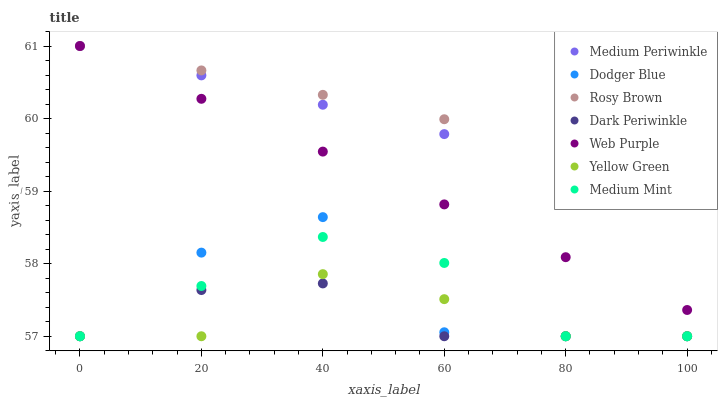Does Dark Periwinkle have the minimum area under the curve?
Answer yes or no. Yes. Does Rosy Brown have the maximum area under the curve?
Answer yes or no. Yes. Does Yellow Green have the minimum area under the curve?
Answer yes or no. No. Does Yellow Green have the maximum area under the curve?
Answer yes or no. No. Is Web Purple the smoothest?
Answer yes or no. Yes. Is Dodger Blue the roughest?
Answer yes or no. Yes. Is Yellow Green the smoothest?
Answer yes or no. No. Is Yellow Green the roughest?
Answer yes or no. No. Does Medium Mint have the lowest value?
Answer yes or no. Yes. Does Rosy Brown have the lowest value?
Answer yes or no. No. Does Web Purple have the highest value?
Answer yes or no. Yes. Does Yellow Green have the highest value?
Answer yes or no. No. Is Yellow Green less than Rosy Brown?
Answer yes or no. Yes. Is Web Purple greater than Dodger Blue?
Answer yes or no. Yes. Does Dark Periwinkle intersect Medium Mint?
Answer yes or no. Yes. Is Dark Periwinkle less than Medium Mint?
Answer yes or no. No. Is Dark Periwinkle greater than Medium Mint?
Answer yes or no. No. Does Yellow Green intersect Rosy Brown?
Answer yes or no. No. 